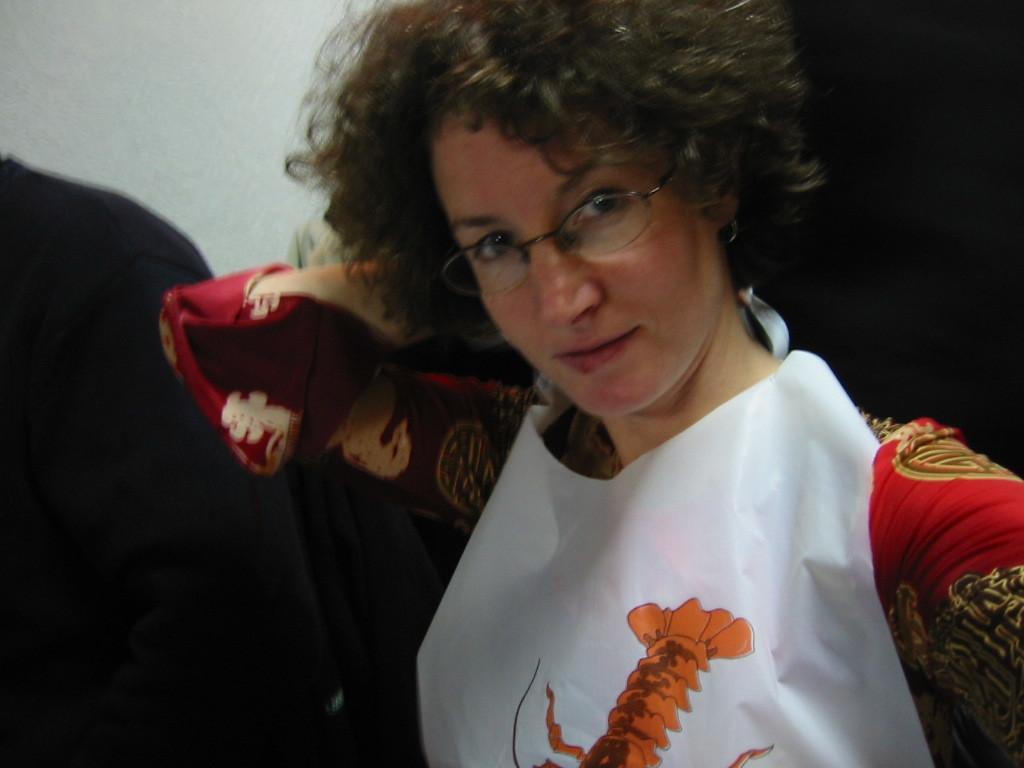Could you give a brief overview of what you see in this image? This image consists of a woman who is wearing red dress. She is also wearing apron. She is wearing specs. She is smiling, beside her there is another person. 